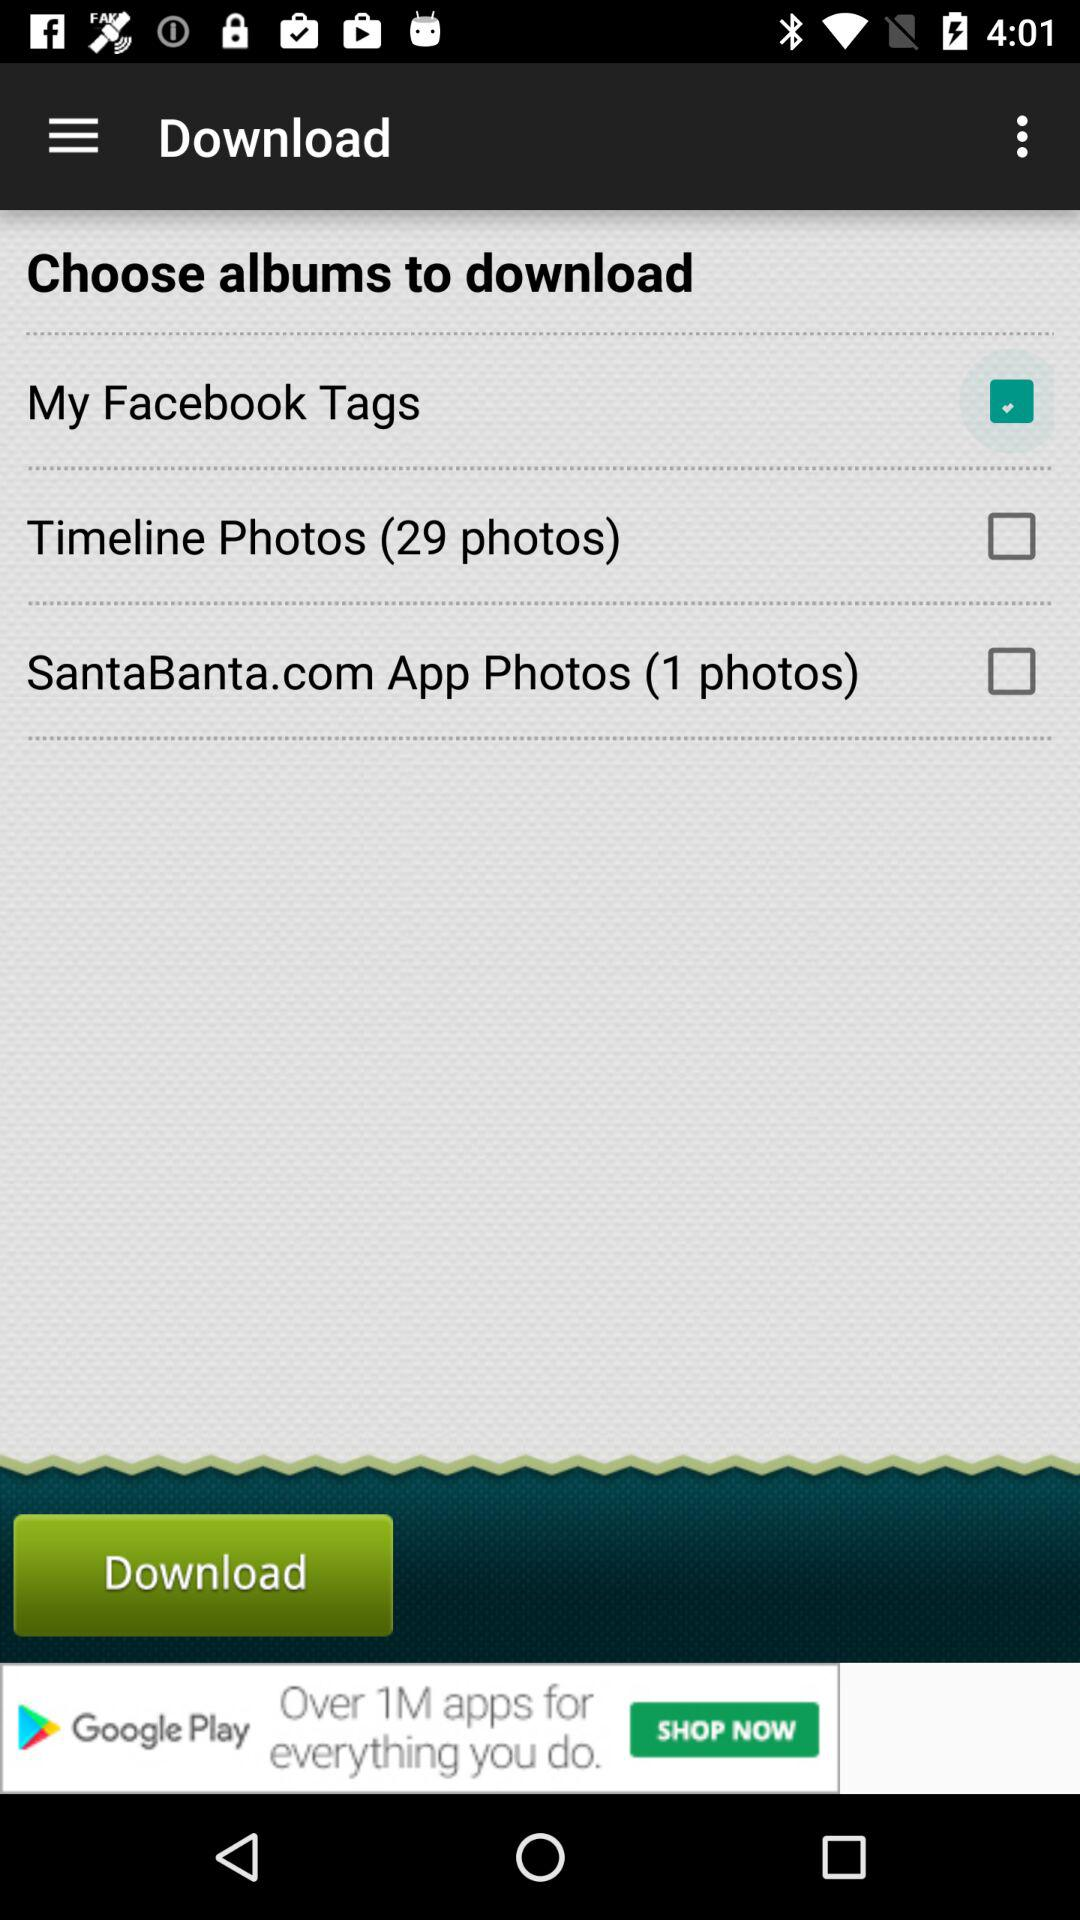What is the status of "My Facebook Tags"? The status of "My Facebook Tags" is "on". 